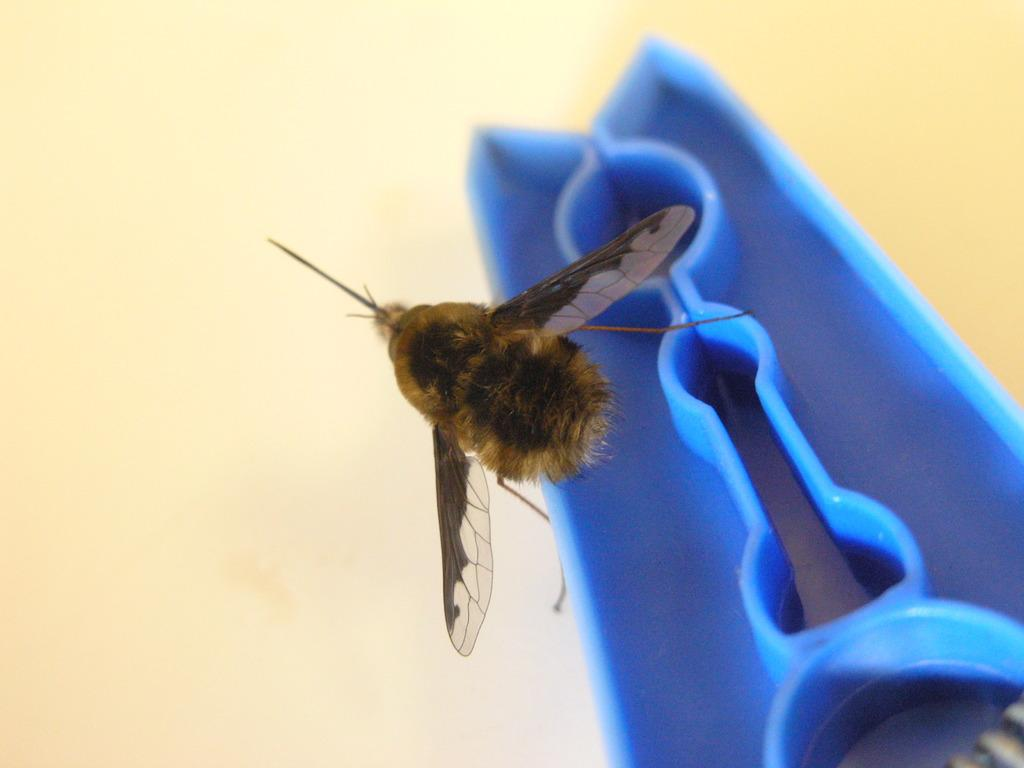What type of creature is present in the image? There is an insect in the image. Can you describe the coloring of the insect? The insect has brown and black coloring. What color is the object in the image? There is a blue colored object in the image. What is the color of the background in the image? The background of the image is cream colored. What type of laborer is working in the image? There is no laborer present in the image; it features an insect and a blue object against a cream-colored background. How many sacks can be seen in the image? There are no sacks present in the image. 